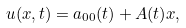<formula> <loc_0><loc_0><loc_500><loc_500>u ( x , t ) = a _ { 0 0 } ( t ) + A ( t ) x ,</formula> 